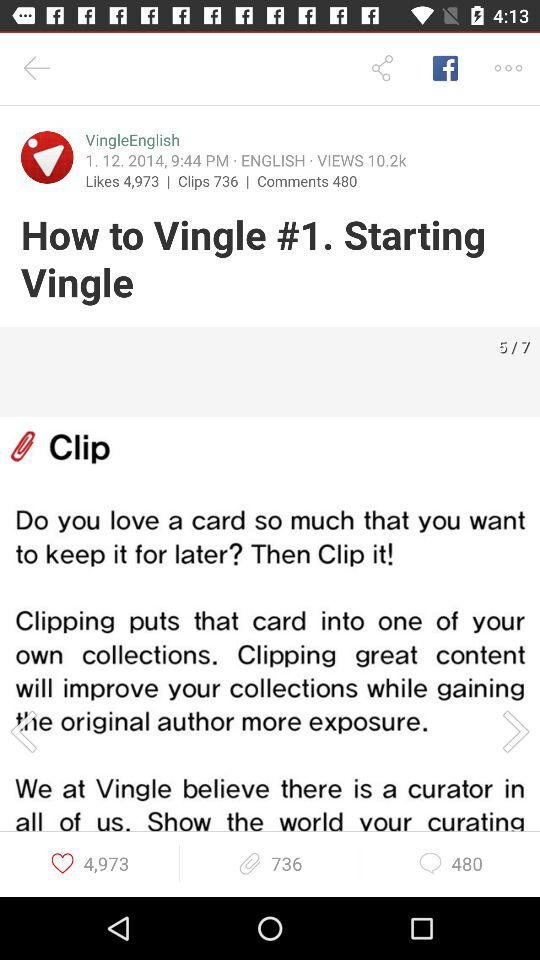What is the date and time? The date and time are January 12, 2014, and 9:44 p.m., respectively. 